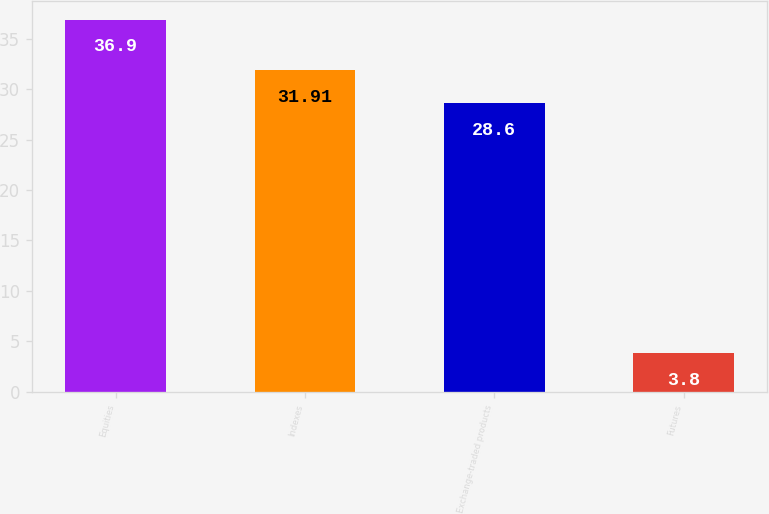Convert chart to OTSL. <chart><loc_0><loc_0><loc_500><loc_500><bar_chart><fcel>Equities<fcel>Indexes<fcel>Exchange-traded products<fcel>Futures<nl><fcel>36.9<fcel>31.91<fcel>28.6<fcel>3.8<nl></chart> 